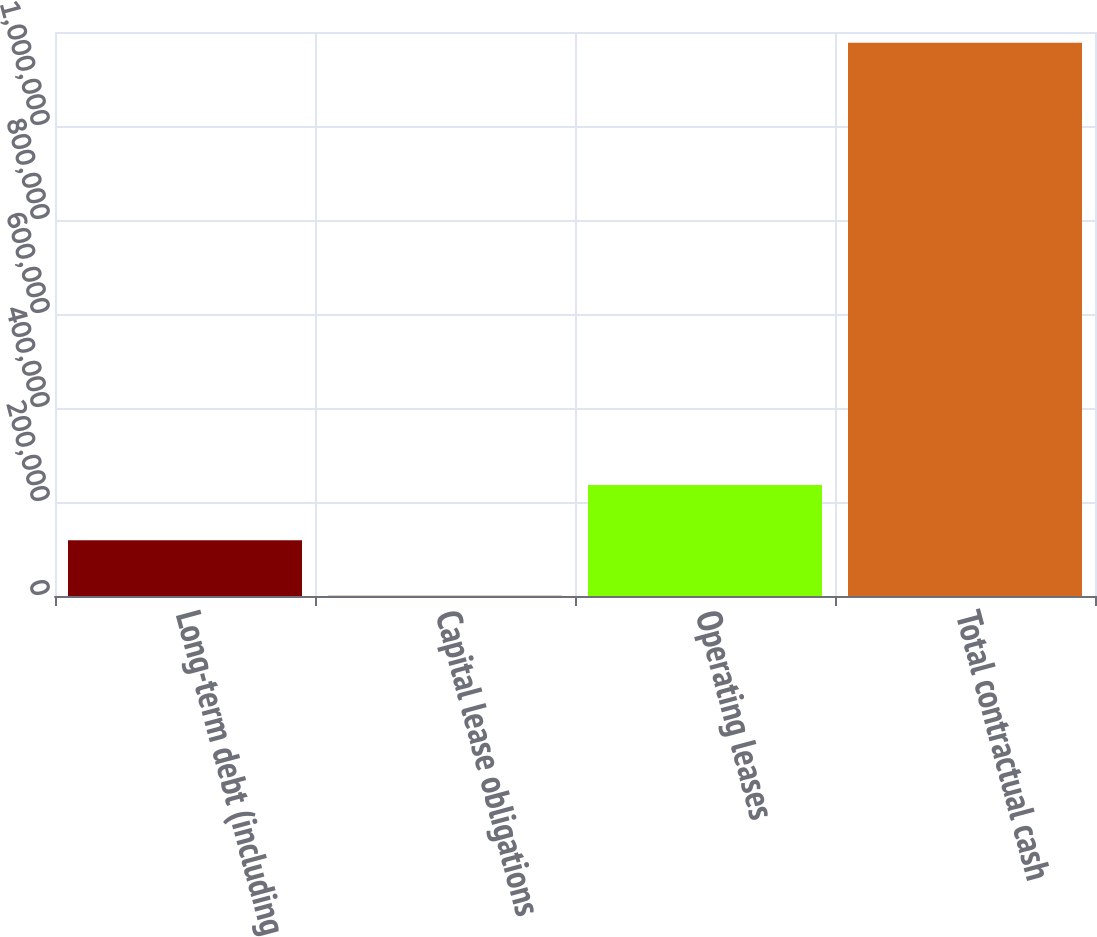<chart> <loc_0><loc_0><loc_500><loc_500><bar_chart><fcel>Long-term debt (including<fcel>Capital lease obligations<fcel>Operating leases<fcel>Total contractual cash<nl><fcel>118359<fcel>722<fcel>235996<fcel>1.17709e+06<nl></chart> 